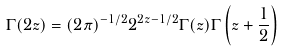<formula> <loc_0><loc_0><loc_500><loc_500>\Gamma ( 2 z ) = ( 2 \pi ) ^ { - 1 / 2 } 2 ^ { 2 z - 1 / 2 } \Gamma ( z ) \Gamma \left ( z + \frac { 1 } { 2 } \right )</formula> 